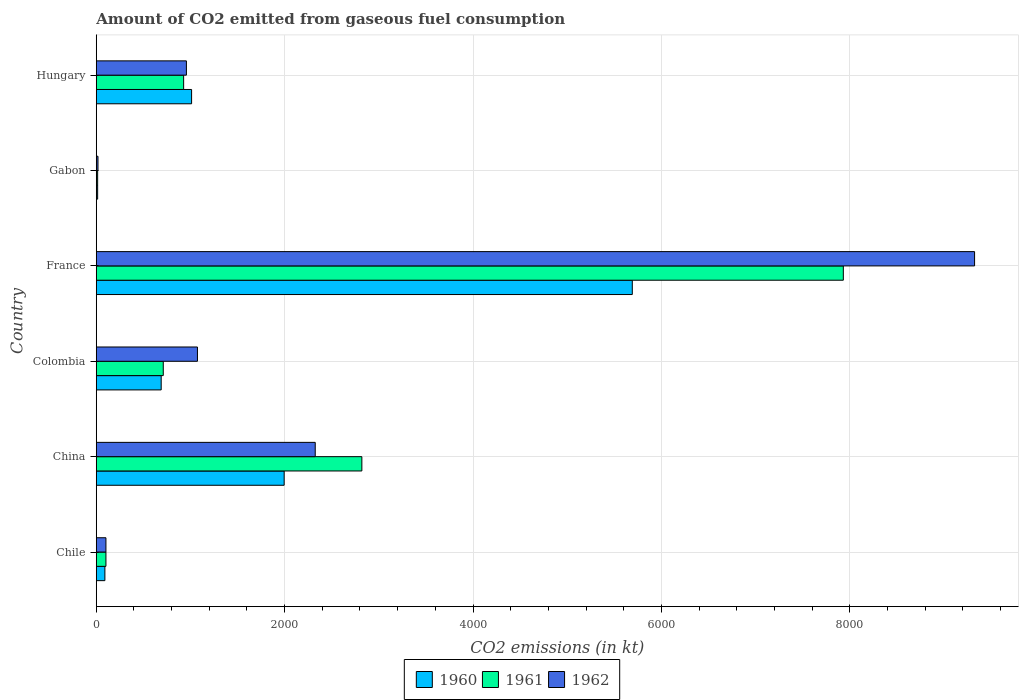How many different coloured bars are there?
Give a very brief answer. 3. Are the number of bars per tick equal to the number of legend labels?
Your answer should be very brief. Yes. How many bars are there on the 3rd tick from the bottom?
Make the answer very short. 3. In how many cases, is the number of bars for a given country not equal to the number of legend labels?
Provide a succinct answer. 0. What is the amount of CO2 emitted in 1960 in Colombia?
Give a very brief answer. 689.4. Across all countries, what is the maximum amount of CO2 emitted in 1962?
Give a very brief answer. 9325.18. Across all countries, what is the minimum amount of CO2 emitted in 1961?
Keep it short and to the point. 14.67. In which country was the amount of CO2 emitted in 1961 maximum?
Ensure brevity in your answer.  France. In which country was the amount of CO2 emitted in 1961 minimum?
Offer a very short reply. Gabon. What is the total amount of CO2 emitted in 1962 in the graph?
Your response must be concise. 1.38e+04. What is the difference between the amount of CO2 emitted in 1962 in Colombia and that in France?
Your answer should be compact. -8250.75. What is the difference between the amount of CO2 emitted in 1962 in Gabon and the amount of CO2 emitted in 1961 in Hungary?
Make the answer very short. -909.42. What is the average amount of CO2 emitted in 1961 per country?
Give a very brief answer. 2084.69. What is the difference between the amount of CO2 emitted in 1961 and amount of CO2 emitted in 1960 in Hungary?
Provide a short and direct response. -84.34. What is the ratio of the amount of CO2 emitted in 1962 in China to that in Colombia?
Make the answer very short. 2.16. Is the amount of CO2 emitted in 1962 in Chile less than that in Hungary?
Ensure brevity in your answer.  Yes. Is the difference between the amount of CO2 emitted in 1961 in Gabon and Hungary greater than the difference between the amount of CO2 emitted in 1960 in Gabon and Hungary?
Ensure brevity in your answer.  Yes. What is the difference between the highest and the second highest amount of CO2 emitted in 1960?
Your answer should be compact. 3696.34. What is the difference between the highest and the lowest amount of CO2 emitted in 1962?
Provide a short and direct response. 9306.85. Is the sum of the amount of CO2 emitted in 1960 in Chile and Colombia greater than the maximum amount of CO2 emitted in 1962 across all countries?
Your response must be concise. No. What does the 2nd bar from the top in Gabon represents?
Provide a short and direct response. 1961. Is it the case that in every country, the sum of the amount of CO2 emitted in 1960 and amount of CO2 emitted in 1962 is greater than the amount of CO2 emitted in 1961?
Offer a very short reply. Yes. How many countries are there in the graph?
Offer a very short reply. 6. Does the graph contain any zero values?
Your answer should be very brief. No. Does the graph contain grids?
Your response must be concise. Yes. Where does the legend appear in the graph?
Provide a short and direct response. Bottom center. How many legend labels are there?
Your response must be concise. 3. How are the legend labels stacked?
Make the answer very short. Horizontal. What is the title of the graph?
Your response must be concise. Amount of CO2 emitted from gaseous fuel consumption. What is the label or title of the X-axis?
Provide a short and direct response. CO2 emissions (in kt). What is the CO2 emissions (in kt) of 1960 in Chile?
Offer a terse response. 91.67. What is the CO2 emissions (in kt) in 1961 in Chile?
Provide a short and direct response. 102.68. What is the CO2 emissions (in kt) in 1962 in Chile?
Give a very brief answer. 102.68. What is the CO2 emissions (in kt) of 1960 in China?
Offer a terse response. 1994.85. What is the CO2 emissions (in kt) in 1961 in China?
Offer a terse response. 2819.92. What is the CO2 emissions (in kt) in 1962 in China?
Make the answer very short. 2324.88. What is the CO2 emissions (in kt) of 1960 in Colombia?
Your answer should be compact. 689.4. What is the CO2 emissions (in kt) in 1961 in Colombia?
Your answer should be compact. 711.4. What is the CO2 emissions (in kt) in 1962 in Colombia?
Offer a very short reply. 1074.43. What is the CO2 emissions (in kt) of 1960 in France?
Your answer should be compact. 5691.18. What is the CO2 emissions (in kt) in 1961 in France?
Give a very brief answer. 7931.72. What is the CO2 emissions (in kt) of 1962 in France?
Offer a terse response. 9325.18. What is the CO2 emissions (in kt) in 1960 in Gabon?
Your response must be concise. 14.67. What is the CO2 emissions (in kt) of 1961 in Gabon?
Your answer should be very brief. 14.67. What is the CO2 emissions (in kt) in 1962 in Gabon?
Your answer should be very brief. 18.34. What is the CO2 emissions (in kt) in 1960 in Hungary?
Your answer should be very brief. 1012.09. What is the CO2 emissions (in kt) in 1961 in Hungary?
Make the answer very short. 927.75. What is the CO2 emissions (in kt) of 1962 in Hungary?
Your answer should be very brief. 957.09. Across all countries, what is the maximum CO2 emissions (in kt) of 1960?
Ensure brevity in your answer.  5691.18. Across all countries, what is the maximum CO2 emissions (in kt) in 1961?
Your answer should be very brief. 7931.72. Across all countries, what is the maximum CO2 emissions (in kt) of 1962?
Offer a terse response. 9325.18. Across all countries, what is the minimum CO2 emissions (in kt) in 1960?
Give a very brief answer. 14.67. Across all countries, what is the minimum CO2 emissions (in kt) in 1961?
Your answer should be very brief. 14.67. Across all countries, what is the minimum CO2 emissions (in kt) in 1962?
Your answer should be compact. 18.34. What is the total CO2 emissions (in kt) of 1960 in the graph?
Provide a succinct answer. 9493.86. What is the total CO2 emissions (in kt) of 1961 in the graph?
Provide a short and direct response. 1.25e+04. What is the total CO2 emissions (in kt) in 1962 in the graph?
Give a very brief answer. 1.38e+04. What is the difference between the CO2 emissions (in kt) of 1960 in Chile and that in China?
Your answer should be very brief. -1903.17. What is the difference between the CO2 emissions (in kt) of 1961 in Chile and that in China?
Give a very brief answer. -2717.25. What is the difference between the CO2 emissions (in kt) of 1962 in Chile and that in China?
Provide a succinct answer. -2222.2. What is the difference between the CO2 emissions (in kt) of 1960 in Chile and that in Colombia?
Your answer should be very brief. -597.72. What is the difference between the CO2 emissions (in kt) of 1961 in Chile and that in Colombia?
Your answer should be compact. -608.72. What is the difference between the CO2 emissions (in kt) of 1962 in Chile and that in Colombia?
Make the answer very short. -971.75. What is the difference between the CO2 emissions (in kt) of 1960 in Chile and that in France?
Keep it short and to the point. -5599.51. What is the difference between the CO2 emissions (in kt) in 1961 in Chile and that in France?
Offer a very short reply. -7829.05. What is the difference between the CO2 emissions (in kt) of 1962 in Chile and that in France?
Provide a short and direct response. -9222.5. What is the difference between the CO2 emissions (in kt) of 1960 in Chile and that in Gabon?
Your answer should be compact. 77.01. What is the difference between the CO2 emissions (in kt) in 1961 in Chile and that in Gabon?
Offer a very short reply. 88.01. What is the difference between the CO2 emissions (in kt) in 1962 in Chile and that in Gabon?
Your answer should be very brief. 84.34. What is the difference between the CO2 emissions (in kt) of 1960 in Chile and that in Hungary?
Make the answer very short. -920.42. What is the difference between the CO2 emissions (in kt) of 1961 in Chile and that in Hungary?
Your answer should be very brief. -825.08. What is the difference between the CO2 emissions (in kt) in 1962 in Chile and that in Hungary?
Your answer should be very brief. -854.41. What is the difference between the CO2 emissions (in kt) of 1960 in China and that in Colombia?
Give a very brief answer. 1305.45. What is the difference between the CO2 emissions (in kt) of 1961 in China and that in Colombia?
Make the answer very short. 2108.53. What is the difference between the CO2 emissions (in kt) in 1962 in China and that in Colombia?
Your answer should be very brief. 1250.45. What is the difference between the CO2 emissions (in kt) of 1960 in China and that in France?
Ensure brevity in your answer.  -3696.34. What is the difference between the CO2 emissions (in kt) in 1961 in China and that in France?
Ensure brevity in your answer.  -5111.8. What is the difference between the CO2 emissions (in kt) of 1962 in China and that in France?
Provide a succinct answer. -7000.3. What is the difference between the CO2 emissions (in kt) of 1960 in China and that in Gabon?
Ensure brevity in your answer.  1980.18. What is the difference between the CO2 emissions (in kt) in 1961 in China and that in Gabon?
Keep it short and to the point. 2805.26. What is the difference between the CO2 emissions (in kt) in 1962 in China and that in Gabon?
Make the answer very short. 2306.54. What is the difference between the CO2 emissions (in kt) of 1960 in China and that in Hungary?
Give a very brief answer. 982.76. What is the difference between the CO2 emissions (in kt) in 1961 in China and that in Hungary?
Provide a succinct answer. 1892.17. What is the difference between the CO2 emissions (in kt) of 1962 in China and that in Hungary?
Provide a succinct answer. 1367.79. What is the difference between the CO2 emissions (in kt) of 1960 in Colombia and that in France?
Offer a terse response. -5001.79. What is the difference between the CO2 emissions (in kt) in 1961 in Colombia and that in France?
Provide a succinct answer. -7220.32. What is the difference between the CO2 emissions (in kt) in 1962 in Colombia and that in France?
Offer a terse response. -8250.75. What is the difference between the CO2 emissions (in kt) in 1960 in Colombia and that in Gabon?
Ensure brevity in your answer.  674.73. What is the difference between the CO2 emissions (in kt) of 1961 in Colombia and that in Gabon?
Your response must be concise. 696.73. What is the difference between the CO2 emissions (in kt) in 1962 in Colombia and that in Gabon?
Offer a terse response. 1056.1. What is the difference between the CO2 emissions (in kt) of 1960 in Colombia and that in Hungary?
Your response must be concise. -322.7. What is the difference between the CO2 emissions (in kt) in 1961 in Colombia and that in Hungary?
Your response must be concise. -216.35. What is the difference between the CO2 emissions (in kt) in 1962 in Colombia and that in Hungary?
Your response must be concise. 117.34. What is the difference between the CO2 emissions (in kt) of 1960 in France and that in Gabon?
Make the answer very short. 5676.52. What is the difference between the CO2 emissions (in kt) in 1961 in France and that in Gabon?
Your answer should be very brief. 7917.05. What is the difference between the CO2 emissions (in kt) of 1962 in France and that in Gabon?
Your answer should be very brief. 9306.85. What is the difference between the CO2 emissions (in kt) of 1960 in France and that in Hungary?
Provide a short and direct response. 4679.09. What is the difference between the CO2 emissions (in kt) in 1961 in France and that in Hungary?
Keep it short and to the point. 7003.97. What is the difference between the CO2 emissions (in kt) in 1962 in France and that in Hungary?
Offer a very short reply. 8368.09. What is the difference between the CO2 emissions (in kt) in 1960 in Gabon and that in Hungary?
Make the answer very short. -997.42. What is the difference between the CO2 emissions (in kt) in 1961 in Gabon and that in Hungary?
Provide a short and direct response. -913.08. What is the difference between the CO2 emissions (in kt) of 1962 in Gabon and that in Hungary?
Your answer should be very brief. -938.75. What is the difference between the CO2 emissions (in kt) of 1960 in Chile and the CO2 emissions (in kt) of 1961 in China?
Your response must be concise. -2728.25. What is the difference between the CO2 emissions (in kt) of 1960 in Chile and the CO2 emissions (in kt) of 1962 in China?
Your response must be concise. -2233.2. What is the difference between the CO2 emissions (in kt) of 1961 in Chile and the CO2 emissions (in kt) of 1962 in China?
Offer a very short reply. -2222.2. What is the difference between the CO2 emissions (in kt) in 1960 in Chile and the CO2 emissions (in kt) in 1961 in Colombia?
Your answer should be compact. -619.72. What is the difference between the CO2 emissions (in kt) of 1960 in Chile and the CO2 emissions (in kt) of 1962 in Colombia?
Your response must be concise. -982.76. What is the difference between the CO2 emissions (in kt) in 1961 in Chile and the CO2 emissions (in kt) in 1962 in Colombia?
Give a very brief answer. -971.75. What is the difference between the CO2 emissions (in kt) in 1960 in Chile and the CO2 emissions (in kt) in 1961 in France?
Ensure brevity in your answer.  -7840.05. What is the difference between the CO2 emissions (in kt) in 1960 in Chile and the CO2 emissions (in kt) in 1962 in France?
Your answer should be compact. -9233.51. What is the difference between the CO2 emissions (in kt) in 1961 in Chile and the CO2 emissions (in kt) in 1962 in France?
Ensure brevity in your answer.  -9222.5. What is the difference between the CO2 emissions (in kt) of 1960 in Chile and the CO2 emissions (in kt) of 1961 in Gabon?
Your answer should be compact. 77.01. What is the difference between the CO2 emissions (in kt) in 1960 in Chile and the CO2 emissions (in kt) in 1962 in Gabon?
Your response must be concise. 73.34. What is the difference between the CO2 emissions (in kt) of 1961 in Chile and the CO2 emissions (in kt) of 1962 in Gabon?
Offer a very short reply. 84.34. What is the difference between the CO2 emissions (in kt) of 1960 in Chile and the CO2 emissions (in kt) of 1961 in Hungary?
Your answer should be compact. -836.08. What is the difference between the CO2 emissions (in kt) in 1960 in Chile and the CO2 emissions (in kt) in 1962 in Hungary?
Offer a very short reply. -865.41. What is the difference between the CO2 emissions (in kt) of 1961 in Chile and the CO2 emissions (in kt) of 1962 in Hungary?
Ensure brevity in your answer.  -854.41. What is the difference between the CO2 emissions (in kt) in 1960 in China and the CO2 emissions (in kt) in 1961 in Colombia?
Make the answer very short. 1283.45. What is the difference between the CO2 emissions (in kt) of 1960 in China and the CO2 emissions (in kt) of 1962 in Colombia?
Give a very brief answer. 920.42. What is the difference between the CO2 emissions (in kt) in 1961 in China and the CO2 emissions (in kt) in 1962 in Colombia?
Offer a terse response. 1745.49. What is the difference between the CO2 emissions (in kt) in 1960 in China and the CO2 emissions (in kt) in 1961 in France?
Your answer should be compact. -5936.87. What is the difference between the CO2 emissions (in kt) of 1960 in China and the CO2 emissions (in kt) of 1962 in France?
Ensure brevity in your answer.  -7330.33. What is the difference between the CO2 emissions (in kt) of 1961 in China and the CO2 emissions (in kt) of 1962 in France?
Keep it short and to the point. -6505.26. What is the difference between the CO2 emissions (in kt) in 1960 in China and the CO2 emissions (in kt) in 1961 in Gabon?
Provide a short and direct response. 1980.18. What is the difference between the CO2 emissions (in kt) of 1960 in China and the CO2 emissions (in kt) of 1962 in Gabon?
Offer a terse response. 1976.51. What is the difference between the CO2 emissions (in kt) in 1961 in China and the CO2 emissions (in kt) in 1962 in Gabon?
Your response must be concise. 2801.59. What is the difference between the CO2 emissions (in kt) of 1960 in China and the CO2 emissions (in kt) of 1961 in Hungary?
Keep it short and to the point. 1067.1. What is the difference between the CO2 emissions (in kt) of 1960 in China and the CO2 emissions (in kt) of 1962 in Hungary?
Your answer should be very brief. 1037.76. What is the difference between the CO2 emissions (in kt) of 1961 in China and the CO2 emissions (in kt) of 1962 in Hungary?
Offer a very short reply. 1862.84. What is the difference between the CO2 emissions (in kt) in 1960 in Colombia and the CO2 emissions (in kt) in 1961 in France?
Make the answer very short. -7242.32. What is the difference between the CO2 emissions (in kt) of 1960 in Colombia and the CO2 emissions (in kt) of 1962 in France?
Your response must be concise. -8635.78. What is the difference between the CO2 emissions (in kt) in 1961 in Colombia and the CO2 emissions (in kt) in 1962 in France?
Your response must be concise. -8613.78. What is the difference between the CO2 emissions (in kt) in 1960 in Colombia and the CO2 emissions (in kt) in 1961 in Gabon?
Your answer should be compact. 674.73. What is the difference between the CO2 emissions (in kt) in 1960 in Colombia and the CO2 emissions (in kt) in 1962 in Gabon?
Provide a succinct answer. 671.06. What is the difference between the CO2 emissions (in kt) of 1961 in Colombia and the CO2 emissions (in kt) of 1962 in Gabon?
Offer a very short reply. 693.06. What is the difference between the CO2 emissions (in kt) of 1960 in Colombia and the CO2 emissions (in kt) of 1961 in Hungary?
Offer a very short reply. -238.35. What is the difference between the CO2 emissions (in kt) in 1960 in Colombia and the CO2 emissions (in kt) in 1962 in Hungary?
Make the answer very short. -267.69. What is the difference between the CO2 emissions (in kt) of 1961 in Colombia and the CO2 emissions (in kt) of 1962 in Hungary?
Your answer should be compact. -245.69. What is the difference between the CO2 emissions (in kt) of 1960 in France and the CO2 emissions (in kt) of 1961 in Gabon?
Your response must be concise. 5676.52. What is the difference between the CO2 emissions (in kt) of 1960 in France and the CO2 emissions (in kt) of 1962 in Gabon?
Your response must be concise. 5672.85. What is the difference between the CO2 emissions (in kt) in 1961 in France and the CO2 emissions (in kt) in 1962 in Gabon?
Your answer should be very brief. 7913.39. What is the difference between the CO2 emissions (in kt) in 1960 in France and the CO2 emissions (in kt) in 1961 in Hungary?
Offer a very short reply. 4763.43. What is the difference between the CO2 emissions (in kt) in 1960 in France and the CO2 emissions (in kt) in 1962 in Hungary?
Make the answer very short. 4734.1. What is the difference between the CO2 emissions (in kt) in 1961 in France and the CO2 emissions (in kt) in 1962 in Hungary?
Make the answer very short. 6974.63. What is the difference between the CO2 emissions (in kt) in 1960 in Gabon and the CO2 emissions (in kt) in 1961 in Hungary?
Make the answer very short. -913.08. What is the difference between the CO2 emissions (in kt) in 1960 in Gabon and the CO2 emissions (in kt) in 1962 in Hungary?
Provide a succinct answer. -942.42. What is the difference between the CO2 emissions (in kt) of 1961 in Gabon and the CO2 emissions (in kt) of 1962 in Hungary?
Ensure brevity in your answer.  -942.42. What is the average CO2 emissions (in kt) of 1960 per country?
Provide a succinct answer. 1582.31. What is the average CO2 emissions (in kt) of 1961 per country?
Offer a very short reply. 2084.69. What is the average CO2 emissions (in kt) of 1962 per country?
Ensure brevity in your answer.  2300.43. What is the difference between the CO2 emissions (in kt) of 1960 and CO2 emissions (in kt) of 1961 in Chile?
Your response must be concise. -11. What is the difference between the CO2 emissions (in kt) of 1960 and CO2 emissions (in kt) of 1962 in Chile?
Offer a terse response. -11. What is the difference between the CO2 emissions (in kt) in 1961 and CO2 emissions (in kt) in 1962 in Chile?
Keep it short and to the point. 0. What is the difference between the CO2 emissions (in kt) of 1960 and CO2 emissions (in kt) of 1961 in China?
Give a very brief answer. -825.08. What is the difference between the CO2 emissions (in kt) of 1960 and CO2 emissions (in kt) of 1962 in China?
Make the answer very short. -330.03. What is the difference between the CO2 emissions (in kt) of 1961 and CO2 emissions (in kt) of 1962 in China?
Provide a succinct answer. 495.05. What is the difference between the CO2 emissions (in kt) of 1960 and CO2 emissions (in kt) of 1961 in Colombia?
Provide a short and direct response. -22. What is the difference between the CO2 emissions (in kt) of 1960 and CO2 emissions (in kt) of 1962 in Colombia?
Ensure brevity in your answer.  -385.04. What is the difference between the CO2 emissions (in kt) of 1961 and CO2 emissions (in kt) of 1962 in Colombia?
Your answer should be compact. -363.03. What is the difference between the CO2 emissions (in kt) in 1960 and CO2 emissions (in kt) in 1961 in France?
Make the answer very short. -2240.54. What is the difference between the CO2 emissions (in kt) in 1960 and CO2 emissions (in kt) in 1962 in France?
Offer a terse response. -3634. What is the difference between the CO2 emissions (in kt) in 1961 and CO2 emissions (in kt) in 1962 in France?
Give a very brief answer. -1393.46. What is the difference between the CO2 emissions (in kt) in 1960 and CO2 emissions (in kt) in 1961 in Gabon?
Ensure brevity in your answer.  0. What is the difference between the CO2 emissions (in kt) in 1960 and CO2 emissions (in kt) in 1962 in Gabon?
Offer a very short reply. -3.67. What is the difference between the CO2 emissions (in kt) in 1961 and CO2 emissions (in kt) in 1962 in Gabon?
Your answer should be compact. -3.67. What is the difference between the CO2 emissions (in kt) in 1960 and CO2 emissions (in kt) in 1961 in Hungary?
Offer a terse response. 84.34. What is the difference between the CO2 emissions (in kt) of 1960 and CO2 emissions (in kt) of 1962 in Hungary?
Offer a very short reply. 55.01. What is the difference between the CO2 emissions (in kt) in 1961 and CO2 emissions (in kt) in 1962 in Hungary?
Make the answer very short. -29.34. What is the ratio of the CO2 emissions (in kt) of 1960 in Chile to that in China?
Offer a terse response. 0.05. What is the ratio of the CO2 emissions (in kt) in 1961 in Chile to that in China?
Offer a terse response. 0.04. What is the ratio of the CO2 emissions (in kt) of 1962 in Chile to that in China?
Your answer should be compact. 0.04. What is the ratio of the CO2 emissions (in kt) in 1960 in Chile to that in Colombia?
Your response must be concise. 0.13. What is the ratio of the CO2 emissions (in kt) of 1961 in Chile to that in Colombia?
Your answer should be compact. 0.14. What is the ratio of the CO2 emissions (in kt) of 1962 in Chile to that in Colombia?
Provide a short and direct response. 0.1. What is the ratio of the CO2 emissions (in kt) in 1960 in Chile to that in France?
Your answer should be compact. 0.02. What is the ratio of the CO2 emissions (in kt) of 1961 in Chile to that in France?
Your response must be concise. 0.01. What is the ratio of the CO2 emissions (in kt) in 1962 in Chile to that in France?
Keep it short and to the point. 0.01. What is the ratio of the CO2 emissions (in kt) in 1960 in Chile to that in Gabon?
Your answer should be compact. 6.25. What is the ratio of the CO2 emissions (in kt) in 1962 in Chile to that in Gabon?
Keep it short and to the point. 5.6. What is the ratio of the CO2 emissions (in kt) in 1960 in Chile to that in Hungary?
Make the answer very short. 0.09. What is the ratio of the CO2 emissions (in kt) in 1961 in Chile to that in Hungary?
Ensure brevity in your answer.  0.11. What is the ratio of the CO2 emissions (in kt) of 1962 in Chile to that in Hungary?
Your answer should be very brief. 0.11. What is the ratio of the CO2 emissions (in kt) in 1960 in China to that in Colombia?
Provide a short and direct response. 2.89. What is the ratio of the CO2 emissions (in kt) in 1961 in China to that in Colombia?
Your response must be concise. 3.96. What is the ratio of the CO2 emissions (in kt) of 1962 in China to that in Colombia?
Ensure brevity in your answer.  2.16. What is the ratio of the CO2 emissions (in kt) of 1960 in China to that in France?
Make the answer very short. 0.35. What is the ratio of the CO2 emissions (in kt) in 1961 in China to that in France?
Keep it short and to the point. 0.36. What is the ratio of the CO2 emissions (in kt) of 1962 in China to that in France?
Your answer should be compact. 0.25. What is the ratio of the CO2 emissions (in kt) in 1960 in China to that in Gabon?
Your answer should be very brief. 136. What is the ratio of the CO2 emissions (in kt) of 1961 in China to that in Gabon?
Your answer should be compact. 192.25. What is the ratio of the CO2 emissions (in kt) in 1962 in China to that in Gabon?
Keep it short and to the point. 126.8. What is the ratio of the CO2 emissions (in kt) of 1960 in China to that in Hungary?
Ensure brevity in your answer.  1.97. What is the ratio of the CO2 emissions (in kt) in 1961 in China to that in Hungary?
Keep it short and to the point. 3.04. What is the ratio of the CO2 emissions (in kt) in 1962 in China to that in Hungary?
Offer a terse response. 2.43. What is the ratio of the CO2 emissions (in kt) in 1960 in Colombia to that in France?
Your response must be concise. 0.12. What is the ratio of the CO2 emissions (in kt) in 1961 in Colombia to that in France?
Give a very brief answer. 0.09. What is the ratio of the CO2 emissions (in kt) of 1962 in Colombia to that in France?
Give a very brief answer. 0.12. What is the ratio of the CO2 emissions (in kt) of 1961 in Colombia to that in Gabon?
Give a very brief answer. 48.5. What is the ratio of the CO2 emissions (in kt) in 1962 in Colombia to that in Gabon?
Give a very brief answer. 58.6. What is the ratio of the CO2 emissions (in kt) in 1960 in Colombia to that in Hungary?
Keep it short and to the point. 0.68. What is the ratio of the CO2 emissions (in kt) in 1961 in Colombia to that in Hungary?
Offer a very short reply. 0.77. What is the ratio of the CO2 emissions (in kt) of 1962 in Colombia to that in Hungary?
Ensure brevity in your answer.  1.12. What is the ratio of the CO2 emissions (in kt) of 1960 in France to that in Gabon?
Your response must be concise. 388. What is the ratio of the CO2 emissions (in kt) in 1961 in France to that in Gabon?
Your answer should be very brief. 540.75. What is the ratio of the CO2 emissions (in kt) of 1962 in France to that in Gabon?
Your response must be concise. 508.6. What is the ratio of the CO2 emissions (in kt) of 1960 in France to that in Hungary?
Your response must be concise. 5.62. What is the ratio of the CO2 emissions (in kt) of 1961 in France to that in Hungary?
Your answer should be very brief. 8.55. What is the ratio of the CO2 emissions (in kt) of 1962 in France to that in Hungary?
Your answer should be very brief. 9.74. What is the ratio of the CO2 emissions (in kt) in 1960 in Gabon to that in Hungary?
Make the answer very short. 0.01. What is the ratio of the CO2 emissions (in kt) of 1961 in Gabon to that in Hungary?
Provide a short and direct response. 0.02. What is the ratio of the CO2 emissions (in kt) in 1962 in Gabon to that in Hungary?
Your answer should be very brief. 0.02. What is the difference between the highest and the second highest CO2 emissions (in kt) of 1960?
Offer a very short reply. 3696.34. What is the difference between the highest and the second highest CO2 emissions (in kt) of 1961?
Offer a very short reply. 5111.8. What is the difference between the highest and the second highest CO2 emissions (in kt) of 1962?
Offer a very short reply. 7000.3. What is the difference between the highest and the lowest CO2 emissions (in kt) of 1960?
Keep it short and to the point. 5676.52. What is the difference between the highest and the lowest CO2 emissions (in kt) of 1961?
Your answer should be very brief. 7917.05. What is the difference between the highest and the lowest CO2 emissions (in kt) of 1962?
Make the answer very short. 9306.85. 